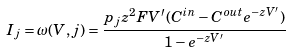Convert formula to latex. <formula><loc_0><loc_0><loc_500><loc_500>I _ { j } = \omega ( V , j ) = \frac { p _ { j } z ^ { 2 } F V ^ { \prime } ( C ^ { i n } - C ^ { o u t } e ^ { - z V ^ { \prime } } ) } { 1 - e ^ { - z V ^ { \prime } } }</formula> 